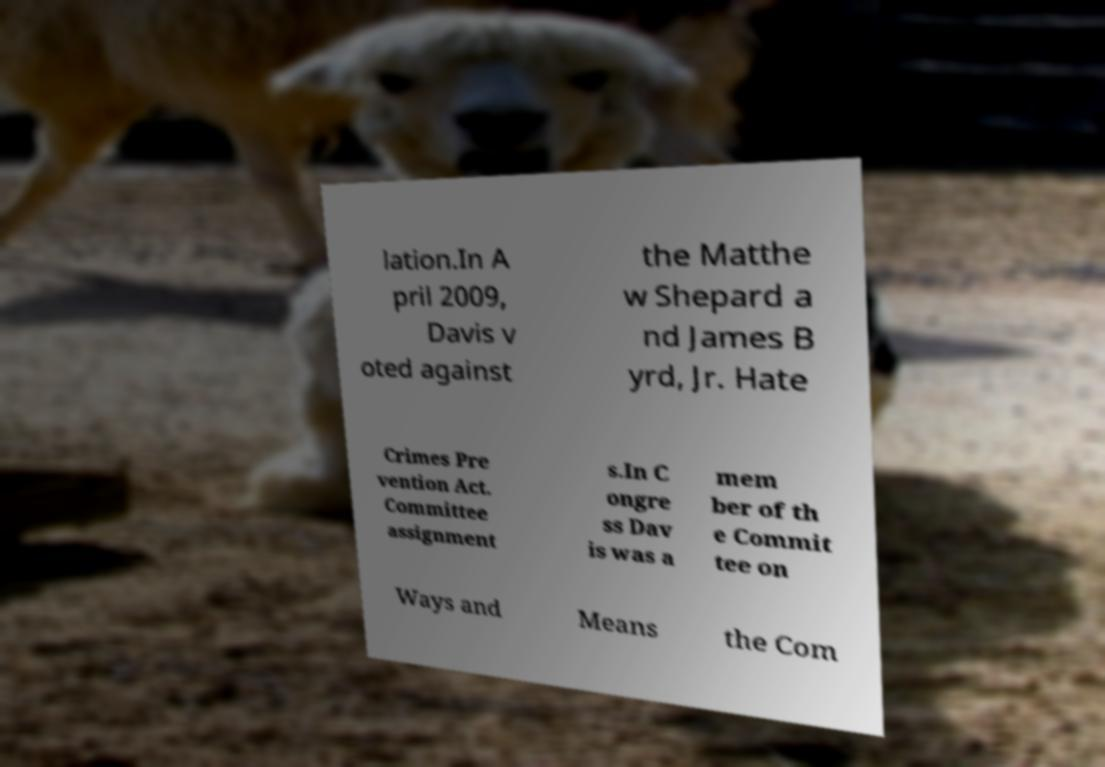Please identify and transcribe the text found in this image. lation.In A pril 2009, Davis v oted against the Matthe w Shepard a nd James B yrd, Jr. Hate Crimes Pre vention Act. Committee assignment s.In C ongre ss Dav is was a mem ber of th e Commit tee on Ways and Means the Com 